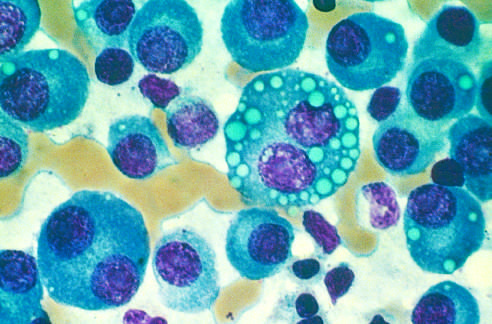re the available anabolic circuits largely replaced by plasma cells, including atypical forms with multiple nuclei, prominent nucleoli, and cyto-plasmic droplets containing immunoglobulin?
Answer the question using a single word or phrase. No 